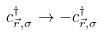Convert formula to latex. <formula><loc_0><loc_0><loc_500><loc_500>c ^ { \dag } _ { \vec { r } , \sigma } \to - c ^ { \dag } _ { \vec { r } , \sigma }</formula> 